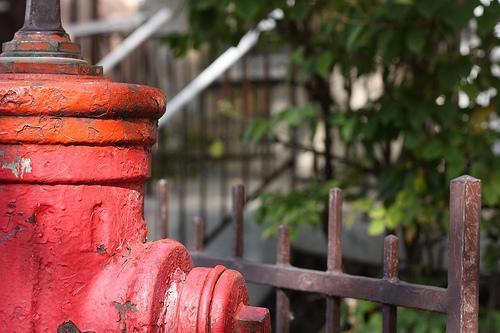How many fire hydrants are in the image?
Give a very brief answer. 1. How many stakes does the gate have going vertical?
Give a very brief answer. 7. 